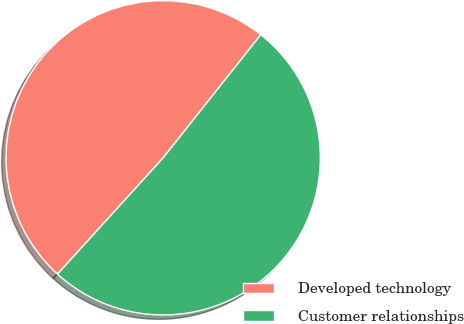<chart> <loc_0><loc_0><loc_500><loc_500><pie_chart><fcel>Developed technology<fcel>Customer relationships<nl><fcel>48.93%<fcel>51.07%<nl></chart> 